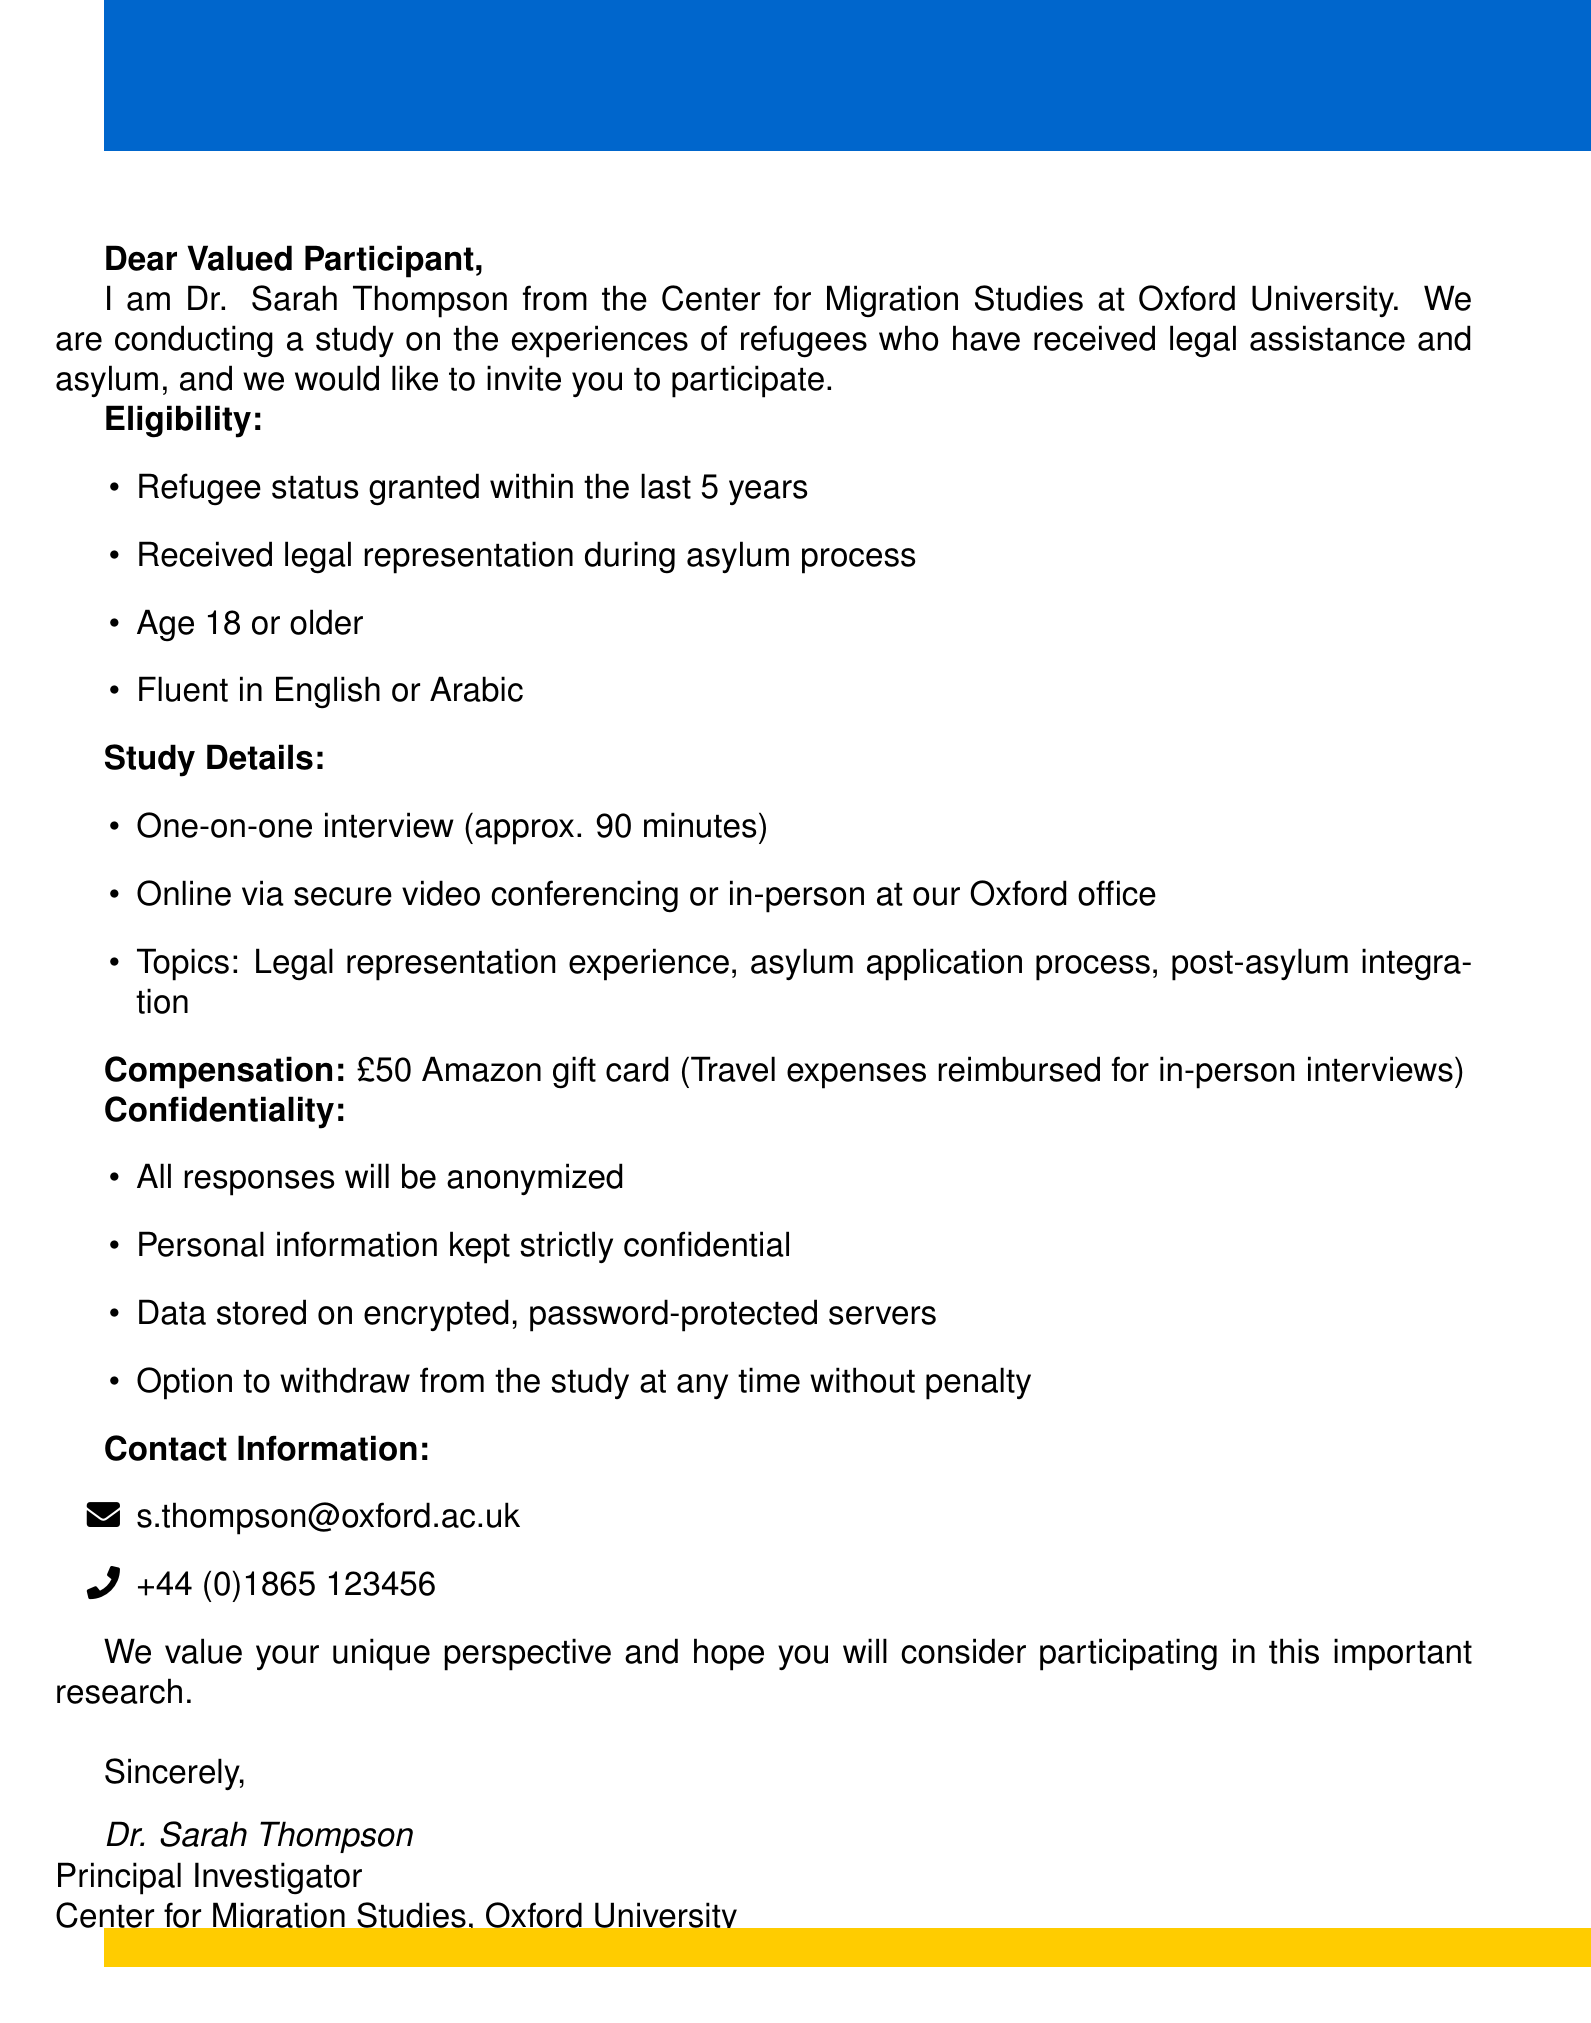What is the name of the researcher conducting the study? The name of the researcher is provided in the introduction of the document.
Answer: Dr. Sarah Thompson What is the location of the study interviews? The document lists the location options for interviews which include online and in-person.
Answer: Online via secure video conferencing or in-person at our Oxford office What is the duration of the interview? The document specifies how long the interviews will last.
Answer: Approximately 90 minutes How much is the compensation for participating in the study? The document mentions the specific amount given as compensation for participation.
Answer: £50 Amazon gift card What languages must participants be fluent in? The eligibility section details the languages required for participation.
Answer: English or Arabic What is the purpose of the study? The document provides a brief overview of the study’s purpose in the introduction.
Answer: Understanding the experiences of refugees who have received legal assistance and asylum What additional benefit is provided for in-person interviews? The document describes any extra benefits associated with attending the interviews in person.
Answer: Travel expenses reimbursed for in-person interviews What measures are outlined for participant confidentiality? The document lists specific confidentiality measures ensuring participant privacy.
Answer: All responses will be anonymized How can participants contact the researcher? The document provides contact information for the researcher involved in the study.
Answer: s.thompson@oxford.ac.uk 